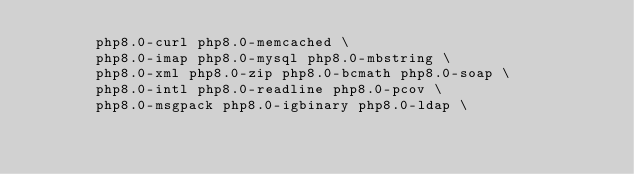Convert code to text. <code><loc_0><loc_0><loc_500><loc_500><_Dockerfile_>       php8.0-curl php8.0-memcached \
       php8.0-imap php8.0-mysql php8.0-mbstring \
       php8.0-xml php8.0-zip php8.0-bcmath php8.0-soap \
       php8.0-intl php8.0-readline php8.0-pcov \
       php8.0-msgpack php8.0-igbinary php8.0-ldap \</code> 